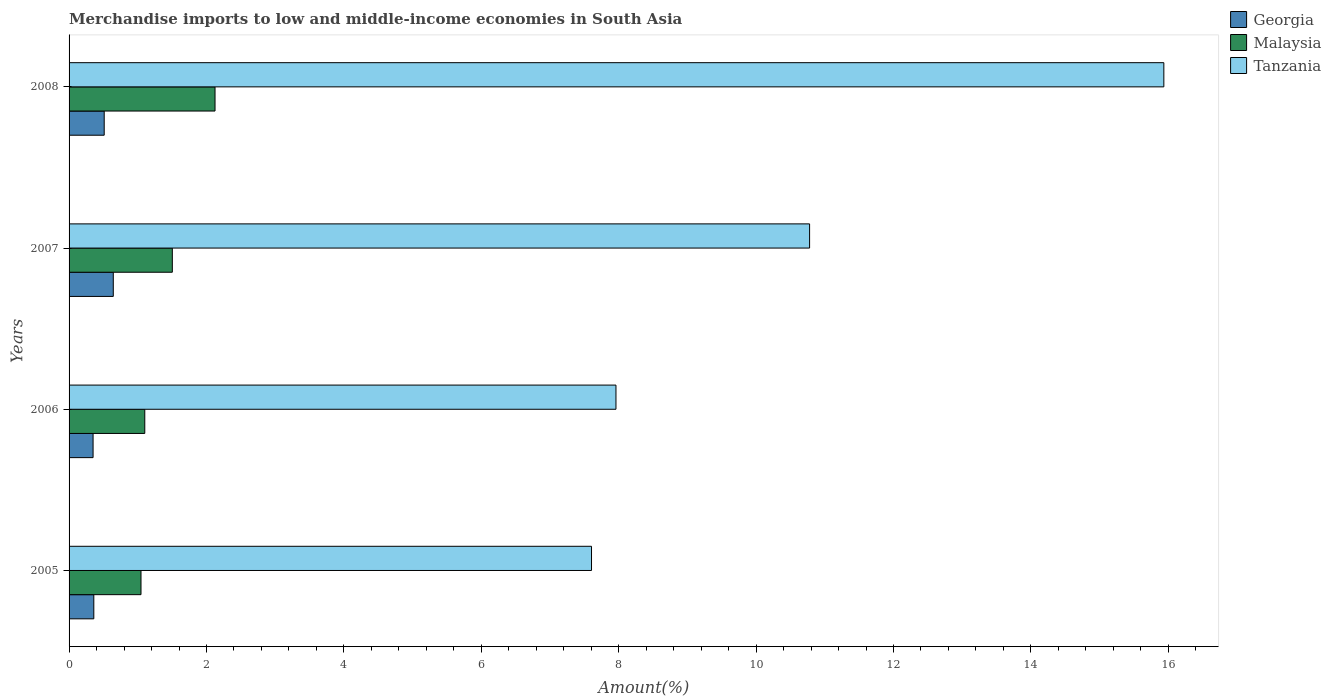How many groups of bars are there?
Provide a short and direct response. 4. Are the number of bars per tick equal to the number of legend labels?
Provide a short and direct response. Yes. How many bars are there on the 3rd tick from the bottom?
Offer a very short reply. 3. What is the percentage of amount earned from merchandise imports in Tanzania in 2006?
Offer a terse response. 7.96. Across all years, what is the maximum percentage of amount earned from merchandise imports in Malaysia?
Provide a succinct answer. 2.12. Across all years, what is the minimum percentage of amount earned from merchandise imports in Tanzania?
Ensure brevity in your answer.  7.6. In which year was the percentage of amount earned from merchandise imports in Tanzania minimum?
Offer a very short reply. 2005. What is the total percentage of amount earned from merchandise imports in Malaysia in the graph?
Provide a succinct answer. 5.78. What is the difference between the percentage of amount earned from merchandise imports in Malaysia in 2006 and that in 2007?
Your answer should be very brief. -0.4. What is the difference between the percentage of amount earned from merchandise imports in Georgia in 2006 and the percentage of amount earned from merchandise imports in Malaysia in 2005?
Give a very brief answer. -0.7. What is the average percentage of amount earned from merchandise imports in Malaysia per year?
Make the answer very short. 1.44. In the year 2006, what is the difference between the percentage of amount earned from merchandise imports in Tanzania and percentage of amount earned from merchandise imports in Georgia?
Your response must be concise. 7.61. What is the ratio of the percentage of amount earned from merchandise imports in Malaysia in 2006 to that in 2007?
Provide a succinct answer. 0.73. What is the difference between the highest and the second highest percentage of amount earned from merchandise imports in Malaysia?
Your response must be concise. 0.62. What is the difference between the highest and the lowest percentage of amount earned from merchandise imports in Malaysia?
Provide a succinct answer. 1.08. Is the sum of the percentage of amount earned from merchandise imports in Tanzania in 2006 and 2007 greater than the maximum percentage of amount earned from merchandise imports in Georgia across all years?
Provide a succinct answer. Yes. What does the 1st bar from the top in 2006 represents?
Offer a terse response. Tanzania. What does the 3rd bar from the bottom in 2006 represents?
Offer a very short reply. Tanzania. How are the legend labels stacked?
Keep it short and to the point. Vertical. What is the title of the graph?
Provide a succinct answer. Merchandise imports to low and middle-income economies in South Asia. Does "Latin America(all income levels)" appear as one of the legend labels in the graph?
Your answer should be compact. No. What is the label or title of the X-axis?
Your answer should be very brief. Amount(%). What is the label or title of the Y-axis?
Provide a short and direct response. Years. What is the Amount(%) in Georgia in 2005?
Your answer should be compact. 0.36. What is the Amount(%) of Malaysia in 2005?
Your answer should be very brief. 1.05. What is the Amount(%) of Tanzania in 2005?
Your response must be concise. 7.6. What is the Amount(%) of Georgia in 2006?
Your response must be concise. 0.35. What is the Amount(%) of Malaysia in 2006?
Provide a short and direct response. 1.1. What is the Amount(%) of Tanzania in 2006?
Make the answer very short. 7.96. What is the Amount(%) in Georgia in 2007?
Your answer should be compact. 0.64. What is the Amount(%) in Malaysia in 2007?
Offer a terse response. 1.5. What is the Amount(%) of Tanzania in 2007?
Your answer should be compact. 10.78. What is the Amount(%) in Georgia in 2008?
Offer a very short reply. 0.51. What is the Amount(%) in Malaysia in 2008?
Keep it short and to the point. 2.12. What is the Amount(%) of Tanzania in 2008?
Your answer should be very brief. 15.94. Across all years, what is the maximum Amount(%) of Georgia?
Your answer should be very brief. 0.64. Across all years, what is the maximum Amount(%) in Malaysia?
Ensure brevity in your answer.  2.12. Across all years, what is the maximum Amount(%) of Tanzania?
Your answer should be compact. 15.94. Across all years, what is the minimum Amount(%) of Georgia?
Make the answer very short. 0.35. Across all years, what is the minimum Amount(%) of Malaysia?
Make the answer very short. 1.05. Across all years, what is the minimum Amount(%) in Tanzania?
Provide a short and direct response. 7.6. What is the total Amount(%) of Georgia in the graph?
Provide a short and direct response. 1.86. What is the total Amount(%) of Malaysia in the graph?
Give a very brief answer. 5.78. What is the total Amount(%) of Tanzania in the graph?
Your response must be concise. 42.28. What is the difference between the Amount(%) in Georgia in 2005 and that in 2006?
Provide a short and direct response. 0.01. What is the difference between the Amount(%) of Malaysia in 2005 and that in 2006?
Keep it short and to the point. -0.06. What is the difference between the Amount(%) in Tanzania in 2005 and that in 2006?
Ensure brevity in your answer.  -0.36. What is the difference between the Amount(%) of Georgia in 2005 and that in 2007?
Your answer should be compact. -0.28. What is the difference between the Amount(%) of Malaysia in 2005 and that in 2007?
Your response must be concise. -0.46. What is the difference between the Amount(%) of Tanzania in 2005 and that in 2007?
Provide a short and direct response. -3.17. What is the difference between the Amount(%) in Georgia in 2005 and that in 2008?
Provide a short and direct response. -0.15. What is the difference between the Amount(%) of Malaysia in 2005 and that in 2008?
Your answer should be very brief. -1.08. What is the difference between the Amount(%) of Tanzania in 2005 and that in 2008?
Give a very brief answer. -8.33. What is the difference between the Amount(%) in Georgia in 2006 and that in 2007?
Your answer should be compact. -0.29. What is the difference between the Amount(%) in Malaysia in 2006 and that in 2007?
Your response must be concise. -0.4. What is the difference between the Amount(%) of Tanzania in 2006 and that in 2007?
Make the answer very short. -2.82. What is the difference between the Amount(%) in Georgia in 2006 and that in 2008?
Offer a terse response. -0.16. What is the difference between the Amount(%) in Malaysia in 2006 and that in 2008?
Ensure brevity in your answer.  -1.02. What is the difference between the Amount(%) in Tanzania in 2006 and that in 2008?
Ensure brevity in your answer.  -7.97. What is the difference between the Amount(%) of Georgia in 2007 and that in 2008?
Ensure brevity in your answer.  0.13. What is the difference between the Amount(%) of Malaysia in 2007 and that in 2008?
Your response must be concise. -0.62. What is the difference between the Amount(%) of Tanzania in 2007 and that in 2008?
Provide a succinct answer. -5.16. What is the difference between the Amount(%) in Georgia in 2005 and the Amount(%) in Malaysia in 2006?
Your answer should be very brief. -0.74. What is the difference between the Amount(%) of Georgia in 2005 and the Amount(%) of Tanzania in 2006?
Keep it short and to the point. -7.6. What is the difference between the Amount(%) in Malaysia in 2005 and the Amount(%) in Tanzania in 2006?
Give a very brief answer. -6.91. What is the difference between the Amount(%) in Georgia in 2005 and the Amount(%) in Malaysia in 2007?
Ensure brevity in your answer.  -1.14. What is the difference between the Amount(%) in Georgia in 2005 and the Amount(%) in Tanzania in 2007?
Provide a succinct answer. -10.42. What is the difference between the Amount(%) of Malaysia in 2005 and the Amount(%) of Tanzania in 2007?
Provide a succinct answer. -9.73. What is the difference between the Amount(%) of Georgia in 2005 and the Amount(%) of Malaysia in 2008?
Ensure brevity in your answer.  -1.76. What is the difference between the Amount(%) of Georgia in 2005 and the Amount(%) of Tanzania in 2008?
Offer a terse response. -15.57. What is the difference between the Amount(%) of Malaysia in 2005 and the Amount(%) of Tanzania in 2008?
Provide a short and direct response. -14.89. What is the difference between the Amount(%) of Georgia in 2006 and the Amount(%) of Malaysia in 2007?
Your answer should be compact. -1.15. What is the difference between the Amount(%) of Georgia in 2006 and the Amount(%) of Tanzania in 2007?
Provide a short and direct response. -10.43. What is the difference between the Amount(%) of Malaysia in 2006 and the Amount(%) of Tanzania in 2007?
Offer a very short reply. -9.68. What is the difference between the Amount(%) of Georgia in 2006 and the Amount(%) of Malaysia in 2008?
Your answer should be compact. -1.77. What is the difference between the Amount(%) in Georgia in 2006 and the Amount(%) in Tanzania in 2008?
Keep it short and to the point. -15.59. What is the difference between the Amount(%) of Malaysia in 2006 and the Amount(%) of Tanzania in 2008?
Provide a succinct answer. -14.83. What is the difference between the Amount(%) in Georgia in 2007 and the Amount(%) in Malaysia in 2008?
Your answer should be compact. -1.48. What is the difference between the Amount(%) in Georgia in 2007 and the Amount(%) in Tanzania in 2008?
Give a very brief answer. -15.29. What is the difference between the Amount(%) in Malaysia in 2007 and the Amount(%) in Tanzania in 2008?
Your response must be concise. -14.43. What is the average Amount(%) of Georgia per year?
Your answer should be very brief. 0.47. What is the average Amount(%) in Malaysia per year?
Keep it short and to the point. 1.44. What is the average Amount(%) in Tanzania per year?
Offer a very short reply. 10.57. In the year 2005, what is the difference between the Amount(%) of Georgia and Amount(%) of Malaysia?
Your answer should be very brief. -0.69. In the year 2005, what is the difference between the Amount(%) in Georgia and Amount(%) in Tanzania?
Your answer should be very brief. -7.24. In the year 2005, what is the difference between the Amount(%) in Malaysia and Amount(%) in Tanzania?
Make the answer very short. -6.56. In the year 2006, what is the difference between the Amount(%) of Georgia and Amount(%) of Malaysia?
Ensure brevity in your answer.  -0.75. In the year 2006, what is the difference between the Amount(%) in Georgia and Amount(%) in Tanzania?
Give a very brief answer. -7.61. In the year 2006, what is the difference between the Amount(%) of Malaysia and Amount(%) of Tanzania?
Keep it short and to the point. -6.86. In the year 2007, what is the difference between the Amount(%) of Georgia and Amount(%) of Malaysia?
Make the answer very short. -0.86. In the year 2007, what is the difference between the Amount(%) of Georgia and Amount(%) of Tanzania?
Provide a succinct answer. -10.13. In the year 2007, what is the difference between the Amount(%) in Malaysia and Amount(%) in Tanzania?
Offer a very short reply. -9.28. In the year 2008, what is the difference between the Amount(%) in Georgia and Amount(%) in Malaysia?
Provide a short and direct response. -1.61. In the year 2008, what is the difference between the Amount(%) of Georgia and Amount(%) of Tanzania?
Give a very brief answer. -15.42. In the year 2008, what is the difference between the Amount(%) in Malaysia and Amount(%) in Tanzania?
Your answer should be compact. -13.81. What is the ratio of the Amount(%) in Georgia in 2005 to that in 2006?
Offer a terse response. 1.03. What is the ratio of the Amount(%) of Malaysia in 2005 to that in 2006?
Offer a terse response. 0.95. What is the ratio of the Amount(%) of Tanzania in 2005 to that in 2006?
Give a very brief answer. 0.96. What is the ratio of the Amount(%) of Georgia in 2005 to that in 2007?
Your response must be concise. 0.56. What is the ratio of the Amount(%) in Malaysia in 2005 to that in 2007?
Provide a short and direct response. 0.7. What is the ratio of the Amount(%) in Tanzania in 2005 to that in 2007?
Your response must be concise. 0.71. What is the ratio of the Amount(%) of Georgia in 2005 to that in 2008?
Your answer should be very brief. 0.7. What is the ratio of the Amount(%) in Malaysia in 2005 to that in 2008?
Make the answer very short. 0.49. What is the ratio of the Amount(%) of Tanzania in 2005 to that in 2008?
Give a very brief answer. 0.48. What is the ratio of the Amount(%) of Georgia in 2006 to that in 2007?
Your response must be concise. 0.54. What is the ratio of the Amount(%) of Malaysia in 2006 to that in 2007?
Give a very brief answer. 0.73. What is the ratio of the Amount(%) of Tanzania in 2006 to that in 2007?
Provide a short and direct response. 0.74. What is the ratio of the Amount(%) of Georgia in 2006 to that in 2008?
Offer a very short reply. 0.68. What is the ratio of the Amount(%) of Malaysia in 2006 to that in 2008?
Keep it short and to the point. 0.52. What is the ratio of the Amount(%) of Tanzania in 2006 to that in 2008?
Your answer should be compact. 0.5. What is the ratio of the Amount(%) of Georgia in 2007 to that in 2008?
Keep it short and to the point. 1.26. What is the ratio of the Amount(%) in Malaysia in 2007 to that in 2008?
Provide a short and direct response. 0.71. What is the ratio of the Amount(%) in Tanzania in 2007 to that in 2008?
Offer a very short reply. 0.68. What is the difference between the highest and the second highest Amount(%) of Georgia?
Offer a very short reply. 0.13. What is the difference between the highest and the second highest Amount(%) of Malaysia?
Ensure brevity in your answer.  0.62. What is the difference between the highest and the second highest Amount(%) of Tanzania?
Your answer should be compact. 5.16. What is the difference between the highest and the lowest Amount(%) in Georgia?
Your response must be concise. 0.29. What is the difference between the highest and the lowest Amount(%) in Malaysia?
Provide a succinct answer. 1.08. What is the difference between the highest and the lowest Amount(%) of Tanzania?
Ensure brevity in your answer.  8.33. 